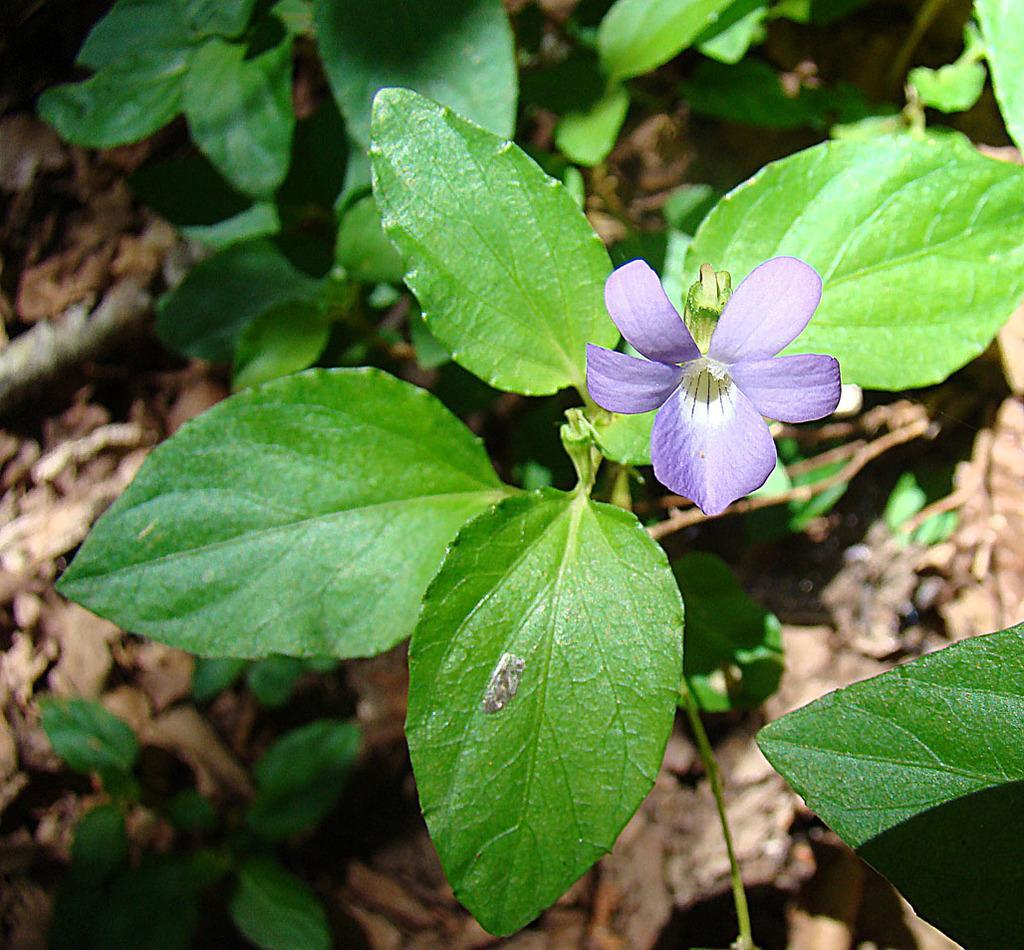Please provide a concise description of this image. There are violet color flower on a plant. In the background there are plants and it is blurred. 